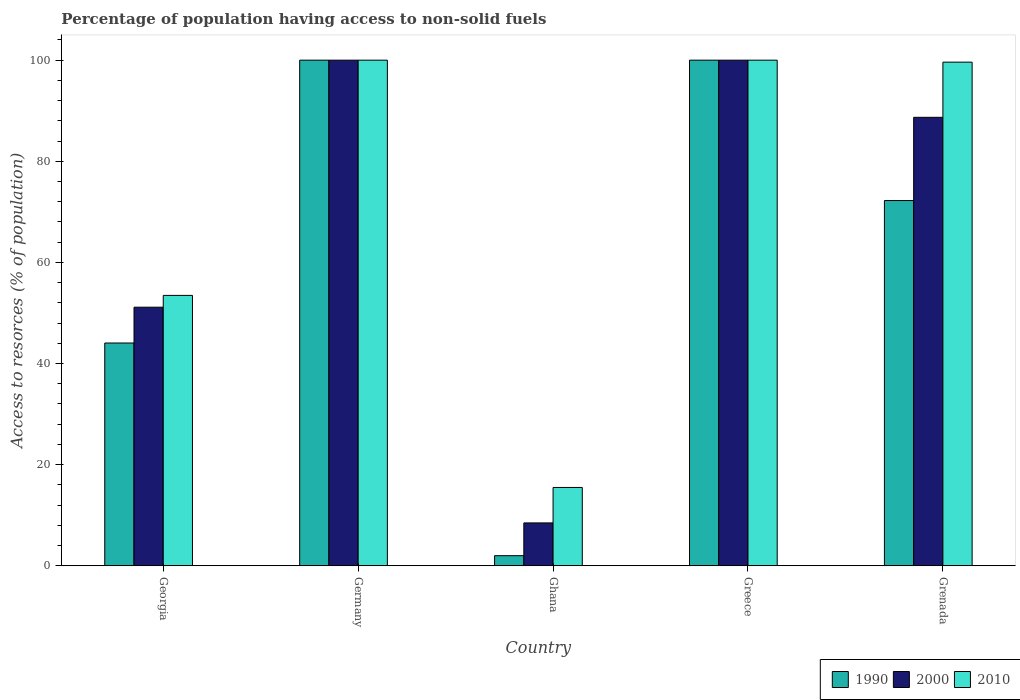How many different coloured bars are there?
Provide a short and direct response. 3. How many groups of bars are there?
Your answer should be compact. 5. Are the number of bars per tick equal to the number of legend labels?
Make the answer very short. Yes. How many bars are there on the 1st tick from the left?
Offer a terse response. 3. How many bars are there on the 2nd tick from the right?
Your response must be concise. 3. What is the label of the 3rd group of bars from the left?
Offer a terse response. Ghana. In how many cases, is the number of bars for a given country not equal to the number of legend labels?
Offer a terse response. 0. What is the percentage of population having access to non-solid fuels in 2010 in Grenada?
Provide a succinct answer. 99.6. Across all countries, what is the minimum percentage of population having access to non-solid fuels in 1990?
Make the answer very short. 2. In which country was the percentage of population having access to non-solid fuels in 2000 minimum?
Ensure brevity in your answer.  Ghana. What is the total percentage of population having access to non-solid fuels in 2000 in the graph?
Make the answer very short. 348.32. What is the difference between the percentage of population having access to non-solid fuels in 2000 in Georgia and that in Grenada?
Ensure brevity in your answer.  -37.55. What is the difference between the percentage of population having access to non-solid fuels in 1990 in Germany and the percentage of population having access to non-solid fuels in 2000 in Ghana?
Provide a succinct answer. 91.52. What is the average percentage of population having access to non-solid fuels in 1990 per country?
Offer a terse response. 63.66. What is the ratio of the percentage of population having access to non-solid fuels in 1990 in Georgia to that in Greece?
Keep it short and to the point. 0.44. Is the percentage of population having access to non-solid fuels in 2010 in Georgia less than that in Ghana?
Keep it short and to the point. No. What is the difference between the highest and the second highest percentage of population having access to non-solid fuels in 2000?
Keep it short and to the point. -11.31. What is the difference between the highest and the lowest percentage of population having access to non-solid fuels in 1990?
Ensure brevity in your answer.  98. Is it the case that in every country, the sum of the percentage of population having access to non-solid fuels in 2000 and percentage of population having access to non-solid fuels in 1990 is greater than the percentage of population having access to non-solid fuels in 2010?
Offer a terse response. No. Are all the bars in the graph horizontal?
Offer a terse response. No. How many legend labels are there?
Your response must be concise. 3. What is the title of the graph?
Your response must be concise. Percentage of population having access to non-solid fuels. What is the label or title of the X-axis?
Your answer should be very brief. Country. What is the label or title of the Y-axis?
Make the answer very short. Access to resorces (% of population). What is the Access to resorces (% of population) in 1990 in Georgia?
Your answer should be very brief. 44.06. What is the Access to resorces (% of population) of 2000 in Georgia?
Make the answer very short. 51.14. What is the Access to resorces (% of population) of 2010 in Georgia?
Give a very brief answer. 53.48. What is the Access to resorces (% of population) of 1990 in Ghana?
Offer a terse response. 2. What is the Access to resorces (% of population) in 2000 in Ghana?
Your answer should be compact. 8.48. What is the Access to resorces (% of population) in 2010 in Ghana?
Your answer should be very brief. 15.49. What is the Access to resorces (% of population) of 1990 in Grenada?
Offer a very short reply. 72.23. What is the Access to resorces (% of population) in 2000 in Grenada?
Offer a terse response. 88.69. What is the Access to resorces (% of population) of 2010 in Grenada?
Make the answer very short. 99.6. Across all countries, what is the maximum Access to resorces (% of population) in 1990?
Provide a succinct answer. 100. Across all countries, what is the maximum Access to resorces (% of population) of 2000?
Your answer should be compact. 100. Across all countries, what is the maximum Access to resorces (% of population) of 2010?
Offer a very short reply. 100. Across all countries, what is the minimum Access to resorces (% of population) of 1990?
Give a very brief answer. 2. Across all countries, what is the minimum Access to resorces (% of population) of 2000?
Your response must be concise. 8.48. Across all countries, what is the minimum Access to resorces (% of population) of 2010?
Offer a very short reply. 15.49. What is the total Access to resorces (% of population) of 1990 in the graph?
Keep it short and to the point. 318.29. What is the total Access to resorces (% of population) of 2000 in the graph?
Your answer should be very brief. 348.32. What is the total Access to resorces (% of population) in 2010 in the graph?
Give a very brief answer. 368.57. What is the difference between the Access to resorces (% of population) of 1990 in Georgia and that in Germany?
Your response must be concise. -55.94. What is the difference between the Access to resorces (% of population) in 2000 in Georgia and that in Germany?
Your response must be concise. -48.86. What is the difference between the Access to resorces (% of population) in 2010 in Georgia and that in Germany?
Keep it short and to the point. -46.52. What is the difference between the Access to resorces (% of population) of 1990 in Georgia and that in Ghana?
Give a very brief answer. 42.06. What is the difference between the Access to resorces (% of population) of 2000 in Georgia and that in Ghana?
Offer a terse response. 42.66. What is the difference between the Access to resorces (% of population) in 2010 in Georgia and that in Ghana?
Provide a succinct answer. 37.99. What is the difference between the Access to resorces (% of population) of 1990 in Georgia and that in Greece?
Offer a terse response. -55.94. What is the difference between the Access to resorces (% of population) of 2000 in Georgia and that in Greece?
Give a very brief answer. -48.86. What is the difference between the Access to resorces (% of population) in 2010 in Georgia and that in Greece?
Give a very brief answer. -46.52. What is the difference between the Access to resorces (% of population) of 1990 in Georgia and that in Grenada?
Offer a very short reply. -28.17. What is the difference between the Access to resorces (% of population) of 2000 in Georgia and that in Grenada?
Your answer should be compact. -37.55. What is the difference between the Access to resorces (% of population) in 2010 in Georgia and that in Grenada?
Offer a very short reply. -46.13. What is the difference between the Access to resorces (% of population) of 2000 in Germany and that in Ghana?
Offer a terse response. 91.52. What is the difference between the Access to resorces (% of population) of 2010 in Germany and that in Ghana?
Keep it short and to the point. 84.51. What is the difference between the Access to resorces (% of population) of 2000 in Germany and that in Greece?
Keep it short and to the point. 0. What is the difference between the Access to resorces (% of population) in 1990 in Germany and that in Grenada?
Your response must be concise. 27.77. What is the difference between the Access to resorces (% of population) in 2000 in Germany and that in Grenada?
Your answer should be very brief. 11.31. What is the difference between the Access to resorces (% of population) of 2010 in Germany and that in Grenada?
Keep it short and to the point. 0.4. What is the difference between the Access to resorces (% of population) of 1990 in Ghana and that in Greece?
Your answer should be very brief. -98. What is the difference between the Access to resorces (% of population) of 2000 in Ghana and that in Greece?
Give a very brief answer. -91.52. What is the difference between the Access to resorces (% of population) in 2010 in Ghana and that in Greece?
Your answer should be compact. -84.51. What is the difference between the Access to resorces (% of population) in 1990 in Ghana and that in Grenada?
Provide a short and direct response. -70.23. What is the difference between the Access to resorces (% of population) of 2000 in Ghana and that in Grenada?
Your answer should be very brief. -80.22. What is the difference between the Access to resorces (% of population) in 2010 in Ghana and that in Grenada?
Your answer should be compact. -84.11. What is the difference between the Access to resorces (% of population) in 1990 in Greece and that in Grenada?
Provide a short and direct response. 27.77. What is the difference between the Access to resorces (% of population) of 2000 in Greece and that in Grenada?
Your response must be concise. 11.31. What is the difference between the Access to resorces (% of population) of 2010 in Greece and that in Grenada?
Give a very brief answer. 0.4. What is the difference between the Access to resorces (% of population) in 1990 in Georgia and the Access to resorces (% of population) in 2000 in Germany?
Provide a succinct answer. -55.94. What is the difference between the Access to resorces (% of population) of 1990 in Georgia and the Access to resorces (% of population) of 2010 in Germany?
Offer a very short reply. -55.94. What is the difference between the Access to resorces (% of population) in 2000 in Georgia and the Access to resorces (% of population) in 2010 in Germany?
Keep it short and to the point. -48.86. What is the difference between the Access to resorces (% of population) in 1990 in Georgia and the Access to resorces (% of population) in 2000 in Ghana?
Ensure brevity in your answer.  35.58. What is the difference between the Access to resorces (% of population) of 1990 in Georgia and the Access to resorces (% of population) of 2010 in Ghana?
Provide a short and direct response. 28.57. What is the difference between the Access to resorces (% of population) in 2000 in Georgia and the Access to resorces (% of population) in 2010 in Ghana?
Your response must be concise. 35.65. What is the difference between the Access to resorces (% of population) in 1990 in Georgia and the Access to resorces (% of population) in 2000 in Greece?
Provide a succinct answer. -55.94. What is the difference between the Access to resorces (% of population) in 1990 in Georgia and the Access to resorces (% of population) in 2010 in Greece?
Keep it short and to the point. -55.94. What is the difference between the Access to resorces (% of population) of 2000 in Georgia and the Access to resorces (% of population) of 2010 in Greece?
Keep it short and to the point. -48.86. What is the difference between the Access to resorces (% of population) in 1990 in Georgia and the Access to resorces (% of population) in 2000 in Grenada?
Your answer should be compact. -44.64. What is the difference between the Access to resorces (% of population) in 1990 in Georgia and the Access to resorces (% of population) in 2010 in Grenada?
Keep it short and to the point. -55.55. What is the difference between the Access to resorces (% of population) of 2000 in Georgia and the Access to resorces (% of population) of 2010 in Grenada?
Keep it short and to the point. -48.46. What is the difference between the Access to resorces (% of population) of 1990 in Germany and the Access to resorces (% of population) of 2000 in Ghana?
Provide a short and direct response. 91.52. What is the difference between the Access to resorces (% of population) of 1990 in Germany and the Access to resorces (% of population) of 2010 in Ghana?
Your answer should be compact. 84.51. What is the difference between the Access to resorces (% of population) of 2000 in Germany and the Access to resorces (% of population) of 2010 in Ghana?
Your answer should be very brief. 84.51. What is the difference between the Access to resorces (% of population) in 1990 in Germany and the Access to resorces (% of population) in 2000 in Grenada?
Offer a very short reply. 11.31. What is the difference between the Access to resorces (% of population) in 1990 in Germany and the Access to resorces (% of population) in 2010 in Grenada?
Your answer should be very brief. 0.4. What is the difference between the Access to resorces (% of population) of 2000 in Germany and the Access to resorces (% of population) of 2010 in Grenada?
Your response must be concise. 0.4. What is the difference between the Access to resorces (% of population) of 1990 in Ghana and the Access to resorces (% of population) of 2000 in Greece?
Your answer should be very brief. -98. What is the difference between the Access to resorces (% of population) in 1990 in Ghana and the Access to resorces (% of population) in 2010 in Greece?
Your answer should be very brief. -98. What is the difference between the Access to resorces (% of population) in 2000 in Ghana and the Access to resorces (% of population) in 2010 in Greece?
Provide a succinct answer. -91.52. What is the difference between the Access to resorces (% of population) of 1990 in Ghana and the Access to resorces (% of population) of 2000 in Grenada?
Your answer should be very brief. -86.69. What is the difference between the Access to resorces (% of population) of 1990 in Ghana and the Access to resorces (% of population) of 2010 in Grenada?
Provide a succinct answer. -97.6. What is the difference between the Access to resorces (% of population) of 2000 in Ghana and the Access to resorces (% of population) of 2010 in Grenada?
Keep it short and to the point. -91.13. What is the difference between the Access to resorces (% of population) in 1990 in Greece and the Access to resorces (% of population) in 2000 in Grenada?
Offer a very short reply. 11.31. What is the difference between the Access to resorces (% of population) of 1990 in Greece and the Access to resorces (% of population) of 2010 in Grenada?
Give a very brief answer. 0.4. What is the difference between the Access to resorces (% of population) in 2000 in Greece and the Access to resorces (% of population) in 2010 in Grenada?
Your response must be concise. 0.4. What is the average Access to resorces (% of population) of 1990 per country?
Provide a short and direct response. 63.66. What is the average Access to resorces (% of population) of 2000 per country?
Give a very brief answer. 69.66. What is the average Access to resorces (% of population) in 2010 per country?
Keep it short and to the point. 73.71. What is the difference between the Access to resorces (% of population) in 1990 and Access to resorces (% of population) in 2000 in Georgia?
Your answer should be very brief. -7.08. What is the difference between the Access to resorces (% of population) of 1990 and Access to resorces (% of population) of 2010 in Georgia?
Make the answer very short. -9.42. What is the difference between the Access to resorces (% of population) of 2000 and Access to resorces (% of population) of 2010 in Georgia?
Ensure brevity in your answer.  -2.33. What is the difference between the Access to resorces (% of population) of 1990 and Access to resorces (% of population) of 2000 in Ghana?
Provide a short and direct response. -6.48. What is the difference between the Access to resorces (% of population) in 1990 and Access to resorces (% of population) in 2010 in Ghana?
Your answer should be compact. -13.49. What is the difference between the Access to resorces (% of population) in 2000 and Access to resorces (% of population) in 2010 in Ghana?
Provide a short and direct response. -7.01. What is the difference between the Access to resorces (% of population) in 1990 and Access to resorces (% of population) in 2000 in Greece?
Make the answer very short. 0. What is the difference between the Access to resorces (% of population) in 1990 and Access to resorces (% of population) in 2010 in Greece?
Keep it short and to the point. 0. What is the difference between the Access to resorces (% of population) of 1990 and Access to resorces (% of population) of 2000 in Grenada?
Your answer should be compact. -16.46. What is the difference between the Access to resorces (% of population) in 1990 and Access to resorces (% of population) in 2010 in Grenada?
Provide a succinct answer. -27.37. What is the difference between the Access to resorces (% of population) of 2000 and Access to resorces (% of population) of 2010 in Grenada?
Provide a short and direct response. -10.91. What is the ratio of the Access to resorces (% of population) in 1990 in Georgia to that in Germany?
Your answer should be compact. 0.44. What is the ratio of the Access to resorces (% of population) in 2000 in Georgia to that in Germany?
Ensure brevity in your answer.  0.51. What is the ratio of the Access to resorces (% of population) of 2010 in Georgia to that in Germany?
Your answer should be compact. 0.53. What is the ratio of the Access to resorces (% of population) in 1990 in Georgia to that in Ghana?
Provide a short and direct response. 22.03. What is the ratio of the Access to resorces (% of population) in 2000 in Georgia to that in Ghana?
Make the answer very short. 6.03. What is the ratio of the Access to resorces (% of population) in 2010 in Georgia to that in Ghana?
Your answer should be compact. 3.45. What is the ratio of the Access to resorces (% of population) in 1990 in Georgia to that in Greece?
Give a very brief answer. 0.44. What is the ratio of the Access to resorces (% of population) of 2000 in Georgia to that in Greece?
Provide a short and direct response. 0.51. What is the ratio of the Access to resorces (% of population) of 2010 in Georgia to that in Greece?
Your response must be concise. 0.53. What is the ratio of the Access to resorces (% of population) of 1990 in Georgia to that in Grenada?
Offer a terse response. 0.61. What is the ratio of the Access to resorces (% of population) of 2000 in Georgia to that in Grenada?
Keep it short and to the point. 0.58. What is the ratio of the Access to resorces (% of population) in 2010 in Georgia to that in Grenada?
Keep it short and to the point. 0.54. What is the ratio of the Access to resorces (% of population) in 1990 in Germany to that in Ghana?
Ensure brevity in your answer.  50. What is the ratio of the Access to resorces (% of population) in 2000 in Germany to that in Ghana?
Your answer should be compact. 11.79. What is the ratio of the Access to resorces (% of population) of 2010 in Germany to that in Ghana?
Provide a succinct answer. 6.46. What is the ratio of the Access to resorces (% of population) of 2000 in Germany to that in Greece?
Make the answer very short. 1. What is the ratio of the Access to resorces (% of population) of 1990 in Germany to that in Grenada?
Your answer should be compact. 1.38. What is the ratio of the Access to resorces (% of population) of 2000 in Germany to that in Grenada?
Give a very brief answer. 1.13. What is the ratio of the Access to resorces (% of population) in 1990 in Ghana to that in Greece?
Provide a succinct answer. 0.02. What is the ratio of the Access to resorces (% of population) of 2000 in Ghana to that in Greece?
Your answer should be very brief. 0.08. What is the ratio of the Access to resorces (% of population) of 2010 in Ghana to that in Greece?
Keep it short and to the point. 0.15. What is the ratio of the Access to resorces (% of population) in 1990 in Ghana to that in Grenada?
Your response must be concise. 0.03. What is the ratio of the Access to resorces (% of population) of 2000 in Ghana to that in Grenada?
Your answer should be very brief. 0.1. What is the ratio of the Access to resorces (% of population) in 2010 in Ghana to that in Grenada?
Ensure brevity in your answer.  0.16. What is the ratio of the Access to resorces (% of population) of 1990 in Greece to that in Grenada?
Offer a terse response. 1.38. What is the ratio of the Access to resorces (% of population) of 2000 in Greece to that in Grenada?
Offer a very short reply. 1.13. What is the difference between the highest and the second highest Access to resorces (% of population) of 2010?
Offer a very short reply. 0. What is the difference between the highest and the lowest Access to resorces (% of population) of 1990?
Make the answer very short. 98. What is the difference between the highest and the lowest Access to resorces (% of population) in 2000?
Offer a very short reply. 91.52. What is the difference between the highest and the lowest Access to resorces (% of population) of 2010?
Ensure brevity in your answer.  84.51. 